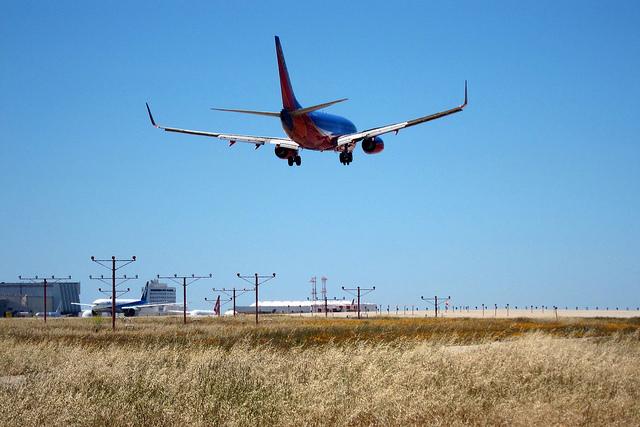How many planes pictured?
Quick response, please. 2. How many people are in the plane?
Answer briefly. 2. Is the plane landing?
Keep it brief. Yes. 